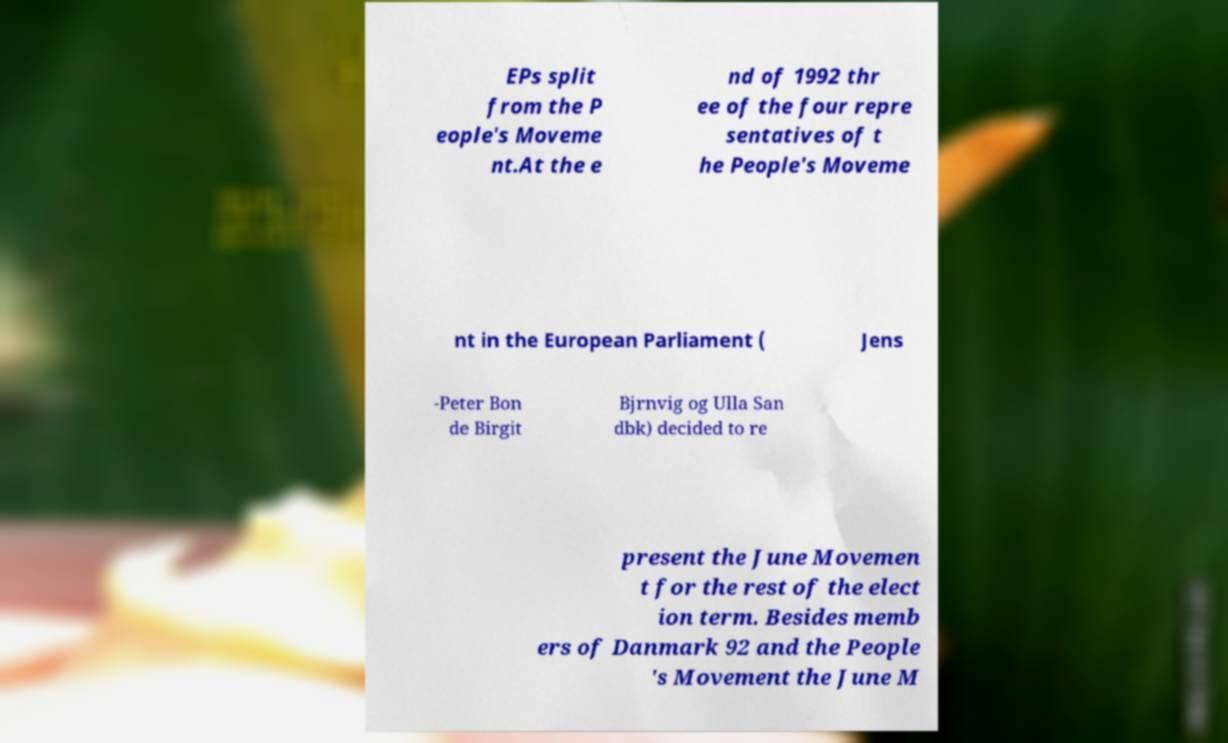Could you assist in decoding the text presented in this image and type it out clearly? EPs split from the P eople's Moveme nt.At the e nd of 1992 thr ee of the four repre sentatives of t he People's Moveme nt in the European Parliament ( Jens -Peter Bon de Birgit Bjrnvig og Ulla San dbk) decided to re present the June Movemen t for the rest of the elect ion term. Besides memb ers of Danmark 92 and the People 's Movement the June M 